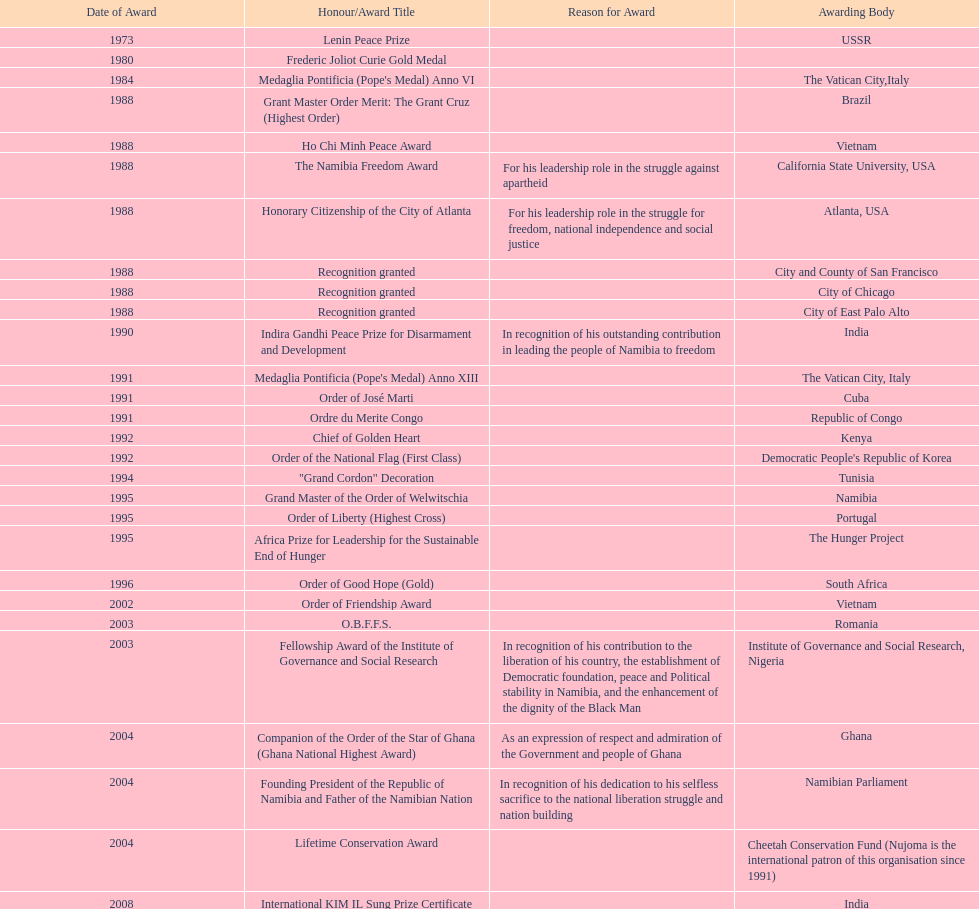What is the latest award nujoma has been honored with? Sir Seretse Khama SADC Meda. 